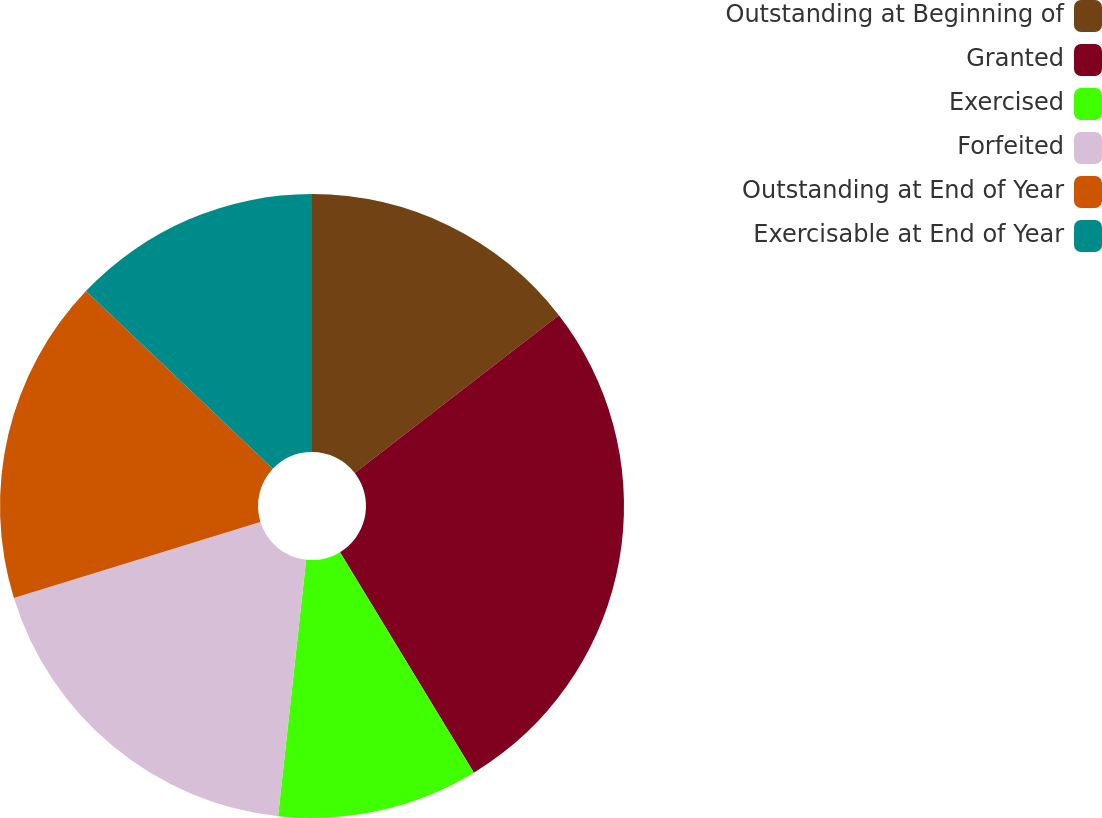<chart> <loc_0><loc_0><loc_500><loc_500><pie_chart><fcel>Outstanding at Beginning of<fcel>Granted<fcel>Exercised<fcel>Forfeited<fcel>Outstanding at End of Year<fcel>Exercisable at End of Year<nl><fcel>14.53%<fcel>26.79%<fcel>10.42%<fcel>18.5%<fcel>16.87%<fcel>12.9%<nl></chart> 